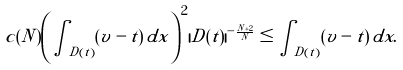Convert formula to latex. <formula><loc_0><loc_0><loc_500><loc_500>c ( N ) \left ( \int _ { D ( t ) } ( v - t ) \, d x \right ) ^ { 2 } | D ( t ) | ^ { - \frac { N + 2 } { N } } \leq \int _ { D ( t ) } ( v - t ) \, d x .</formula> 